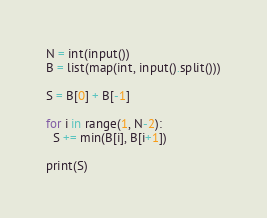Convert code to text. <code><loc_0><loc_0><loc_500><loc_500><_Python_>N = int(input())
B = list(map(int, input().split()))

S = B[0] + B[-1]

for i in range(1, N-2):
  S += min(B[i], B[i+1])

print(S)</code> 